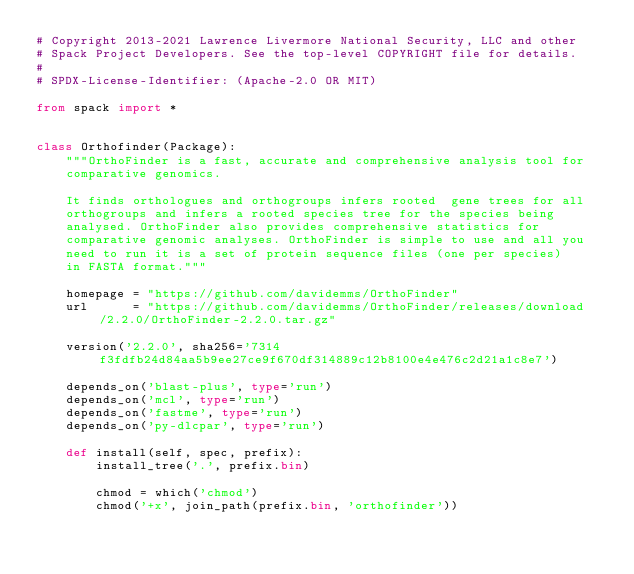Convert code to text. <code><loc_0><loc_0><loc_500><loc_500><_Python_># Copyright 2013-2021 Lawrence Livermore National Security, LLC and other
# Spack Project Developers. See the top-level COPYRIGHT file for details.
#
# SPDX-License-Identifier: (Apache-2.0 OR MIT)

from spack import *


class Orthofinder(Package):
    """OrthoFinder is a fast, accurate and comprehensive analysis tool for
    comparative genomics.

    It finds orthologues and orthogroups infers rooted  gene trees for all
    orthogroups and infers a rooted species tree for the species being
    analysed. OrthoFinder also provides comprehensive statistics for
    comparative genomic analyses. OrthoFinder is simple to use and all you
    need to run it is a set of protein sequence files (one per species)
    in FASTA format."""

    homepage = "https://github.com/davidemms/OrthoFinder"
    url      = "https://github.com/davidemms/OrthoFinder/releases/download/2.2.0/OrthoFinder-2.2.0.tar.gz"

    version('2.2.0', sha256='7314f3fdfb24d84aa5b9ee27ce9f670df314889c12b8100e4e476c2d21a1c8e7')

    depends_on('blast-plus', type='run')
    depends_on('mcl', type='run')
    depends_on('fastme', type='run')
    depends_on('py-dlcpar', type='run')

    def install(self, spec, prefix):
        install_tree('.', prefix.bin)

        chmod = which('chmod')
        chmod('+x', join_path(prefix.bin, 'orthofinder'))
</code> 